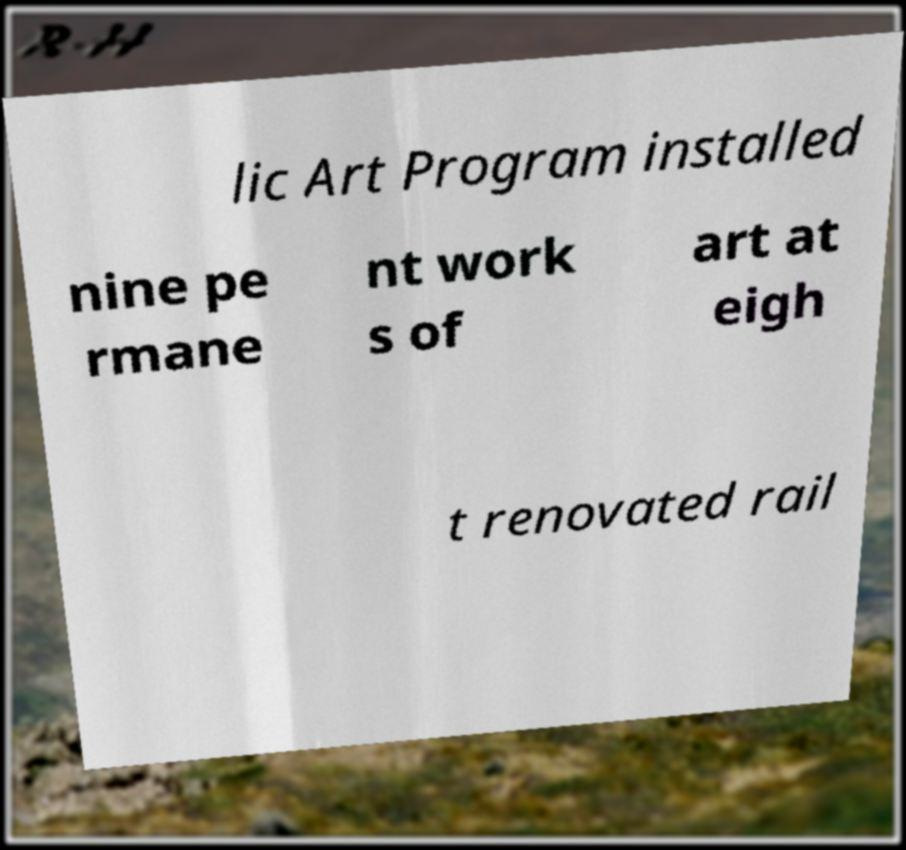Please read and relay the text visible in this image. What does it say? lic Art Program installed nine pe rmane nt work s of art at eigh t renovated rail 